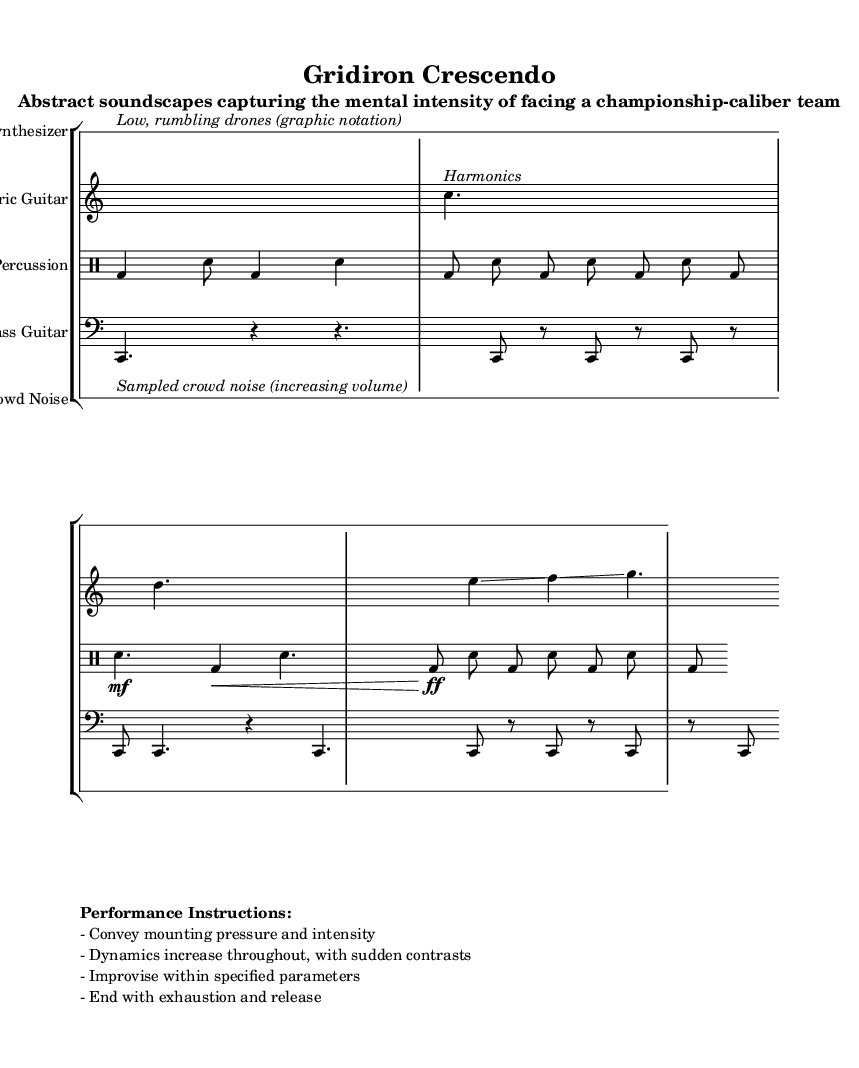What is the time signature of this music? The time signature is indicated at the start of the staves, and it shows a 7/8 time, which suggests an asymmetrical meter consisting of seven eighth notes per measure.
Answer: 7/8 What instrument plays the low rumbling drones? The description for the instrument is given within the notation, indicating that the low, rumbling drones are played by the synthesizer.
Answer: Synthesizer How many measures are in the drum section? The percussion part consists of four measures, as each line of drum notation is separated by a barline, indicating the start and end of a measure.
Answer: Four Which instrument is responsible for the harmonics? The notation clearly labels the electric guitar, as described in the performance instructions and notated with harmonics in the score part.
Answer: Electric Guitar What is the dynamic indication for the final measure of the percussion line? The final measure of the percussion line indicates a fortissimo dynamic (ff), suggesting a very loud playing intensity, corresponding to the mounting pressure.
Answer: Fortissimo How does the piece convey the concept of mounting pressure? The score features instructions to increase dynamics throughout, with unexpected contrasts leading to an overall build-up before ending in exhaustion, reflecting the mental intensity associated with facing a formidable opponent.
Answer: Dynamics increase throughout 